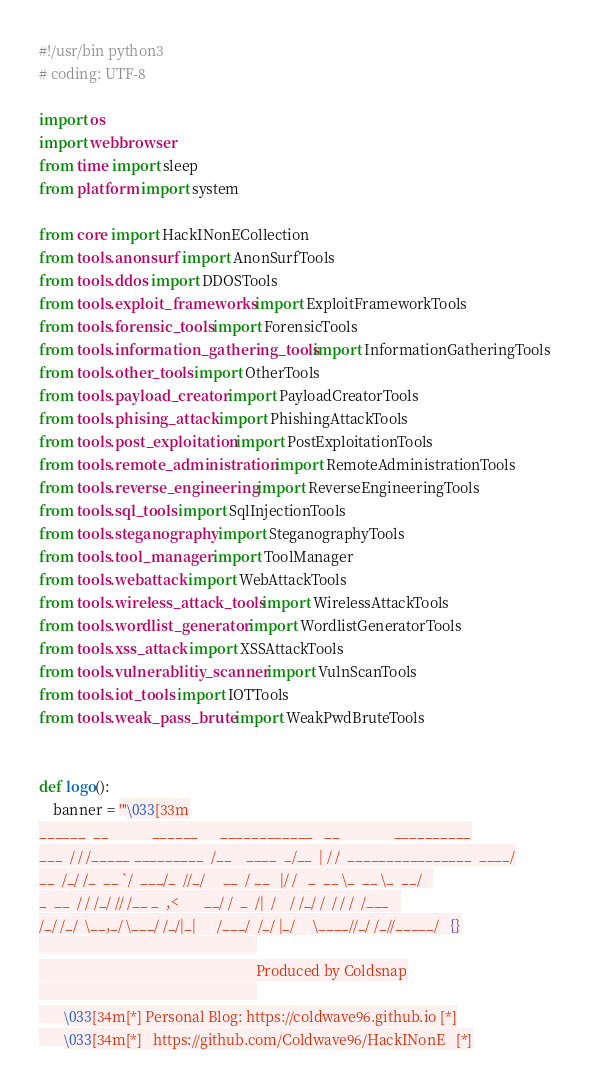<code> <loc_0><loc_0><loc_500><loc_500><_Python_>#!/usr/bin python3
# coding: UTF-8

import os
import webbrowser
from time import sleep
from platform import system

from core import HackINonECollection
from tools.anonsurf import AnonSurfTools
from tools.ddos import DDOSTools
from tools.exploit_frameworks import ExploitFrameworkTools
from tools.forensic_tools import ForensicTools
from tools.information_gathering_tools import InformationGatheringTools
from tools.other_tools import OtherTools
from tools.payload_creator import PayloadCreatorTools
from tools.phising_attack import PhishingAttackTools
from tools.post_exploitation import PostExploitationTools
from tools.remote_administration import RemoteAdministrationTools
from tools.reverse_engineering import ReverseEngineeringTools
from tools.sql_tools import SqlInjectionTools
from tools.steganography import SteganographyTools
from tools.tool_manager import ToolManager
from tools.webattack import WebAttackTools
from tools.wireless_attack_tools import WirelessAttackTools
from tools.wordlist_generator import WordlistGeneratorTools
from tools.xss_attack import XSSAttackTools
from tools.vulnerablitiy_scanner import VulnScanTools
from tools.iot_tools import IOTTools
from tools.weak_pass_brute import WeakPwdBruteTools


def logo():
    banner = '''\033[33m
______  __            ______      ____________   __               __________
___  / / /_____ _________  /__    ____  _/__  | / /  ________________  ____/
__  /_/ /_  __ `/  ___/_  //_/     __  / __   |/ /   _  __ \_  __ \_  __/   
_  __  / / /_/ // /__ _  ,<       __/ /  _  /|  /    / /_/ /  / / /  /___   
/_/ /_/  \__,_/ \___/ /_/|_|      /___/  /_/ |_/     \____//_/ /_//_____/   {}
                                                            
                                                            Produced by Coldsnap
                                                            
       \033[34m[*] Personal Blog: https://coldwave96.github.io [*]
       \033[34m[*]   https://github.com/Coldwave96/HackINonE   [*]</code> 